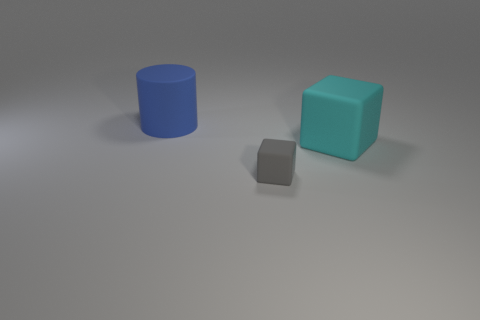How many objects are either blue matte objects or tiny rubber objects that are in front of the big rubber cube?
Give a very brief answer. 2. What number of cyan objects are either rubber blocks or small rubber cubes?
Make the answer very short. 1. There is a matte thing in front of the matte cube right of the gray block; is there a cyan matte thing on the right side of it?
Offer a terse response. Yes. Is there any other thing that is the same size as the gray rubber object?
Give a very brief answer. No. Is the tiny matte thing the same color as the large cylinder?
Give a very brief answer. No. There is a rubber block in front of the object on the right side of the tiny thing; what color is it?
Provide a succinct answer. Gray. How many large things are metal things or gray rubber things?
Provide a short and direct response. 0. What color is the rubber thing that is both behind the gray thing and to the left of the cyan matte block?
Your response must be concise. Blue. Is the material of the large cylinder the same as the gray cube?
Your answer should be compact. Yes. The big cyan thing has what shape?
Provide a short and direct response. Cube. 